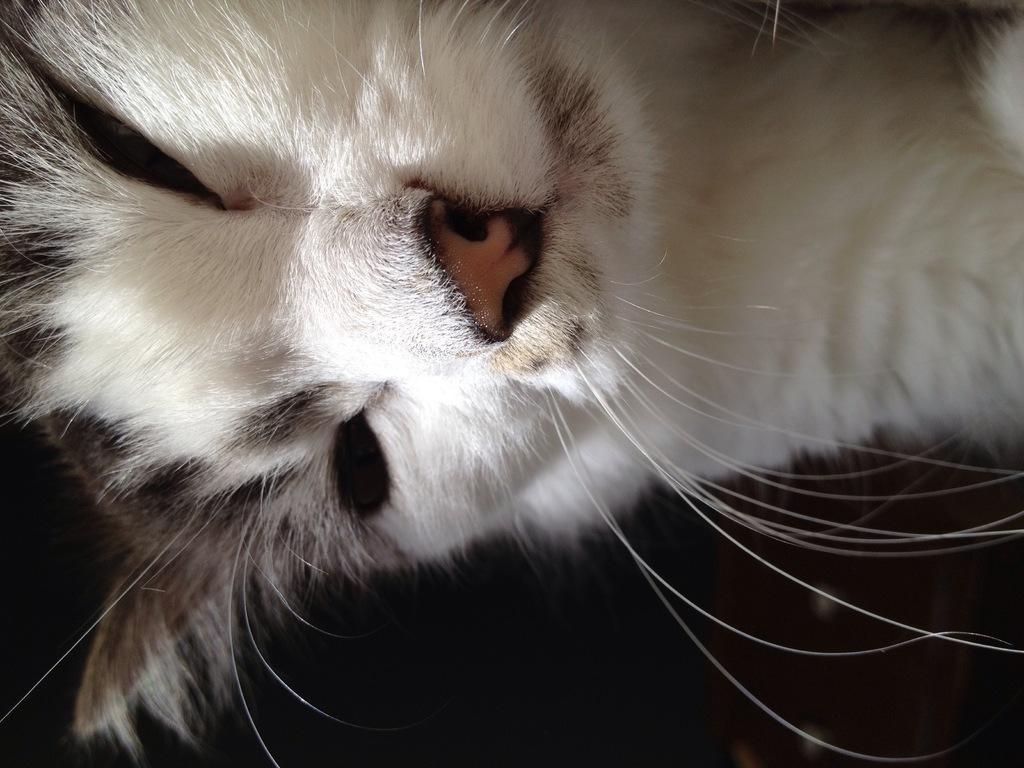Describe this image in one or two sentences. In the foreground of this image, there is a cat and the background image is dark. 